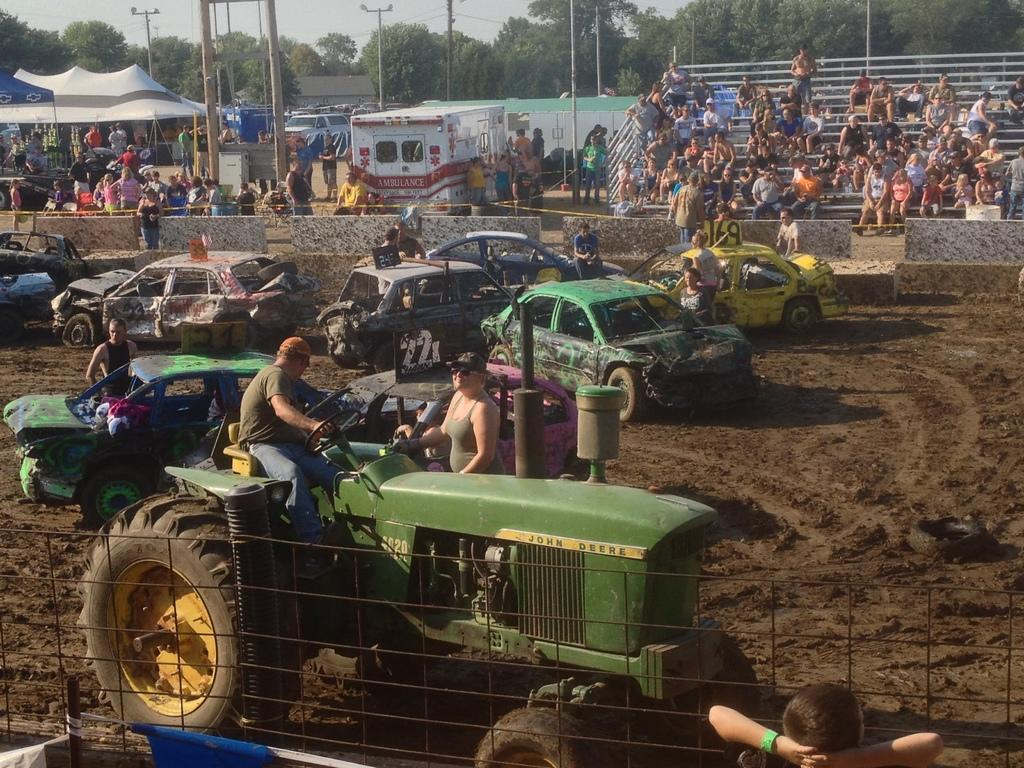What types of objects can be seen in the image? There are vehicles, a fence, crows, poles, trees, tents, and a wall visible in the image. Can you describe the setting of the image? The image appears to be outdoors, with trees, a wall, and a fence present. What is visible in the background of the image? The sky is visible in the background of the image. How many types of structures are present in the image? There are at least three types of structures: a fence, a wall, and tents. What type of drug is being administered to the crows in the image? There is no indication in the image that any drug is being administered to the crows, and therefore no such activity can be observed. What are the crows learning in the image? There is no indication in the image that the crows are learning anything, and therefore no such activity can be observed. 